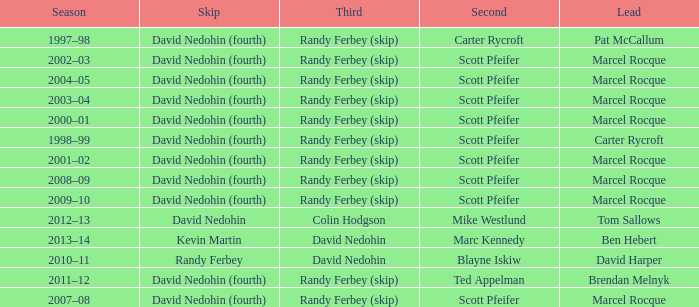Which Third has a Second of scott pfeifer? Randy Ferbey (skip), Randy Ferbey (skip), Randy Ferbey (skip), Randy Ferbey (skip), Randy Ferbey (skip), Randy Ferbey (skip), Randy Ferbey (skip), Randy Ferbey (skip), Randy Ferbey (skip). 